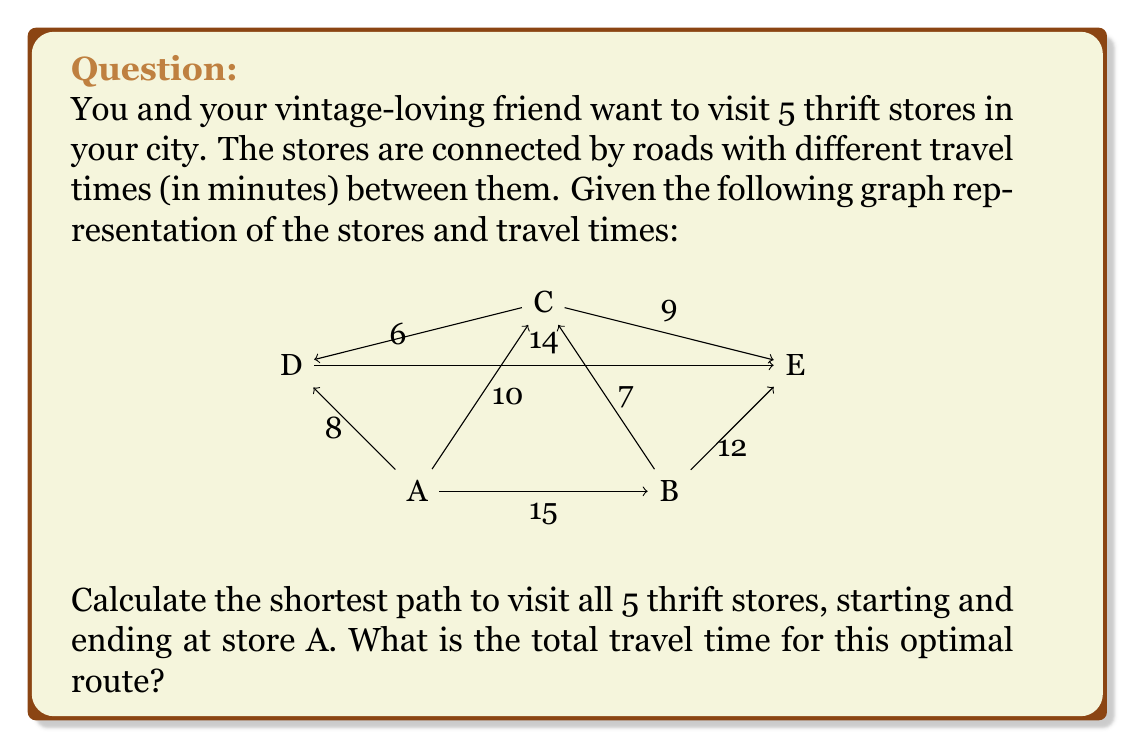What is the answer to this math problem? To solve this problem, we'll use the Traveling Salesman Problem (TSP) approach, which is a classic application of graph theory. Since we have a small number of vertices, we can use a brute-force method to find the optimal solution.

Step 1: List all possible routes starting and ending at A.
There are $(5-1)! = 24$ possible routes.

Step 2: Calculate the total travel time for each route.
For example:
A → B → C → D → E → A = 15 + 7 + 6 + 14 + 12 = 54 minutes
A → B → C → E → D → A = 15 + 7 + 9 + 14 + 8 = 53 minutes
...and so on for all 24 routes.

Step 3: Identify the route with the minimum total travel time.
After calculating all routes, we find that the shortest path is:
A → D → C → B → E → A

Step 4: Calculate the total travel time for the optimal route.
A → D: 8 minutes
D → C: 6 minutes
C → B: 7 minutes
B → E: 12 minutes
E → A: 12 minutes (since the graph is undirected, we assume E → A takes the same time as A → E)

Total travel time = 8 + 6 + 7 + 12 + 12 = 45 minutes
Answer: 45 minutes 